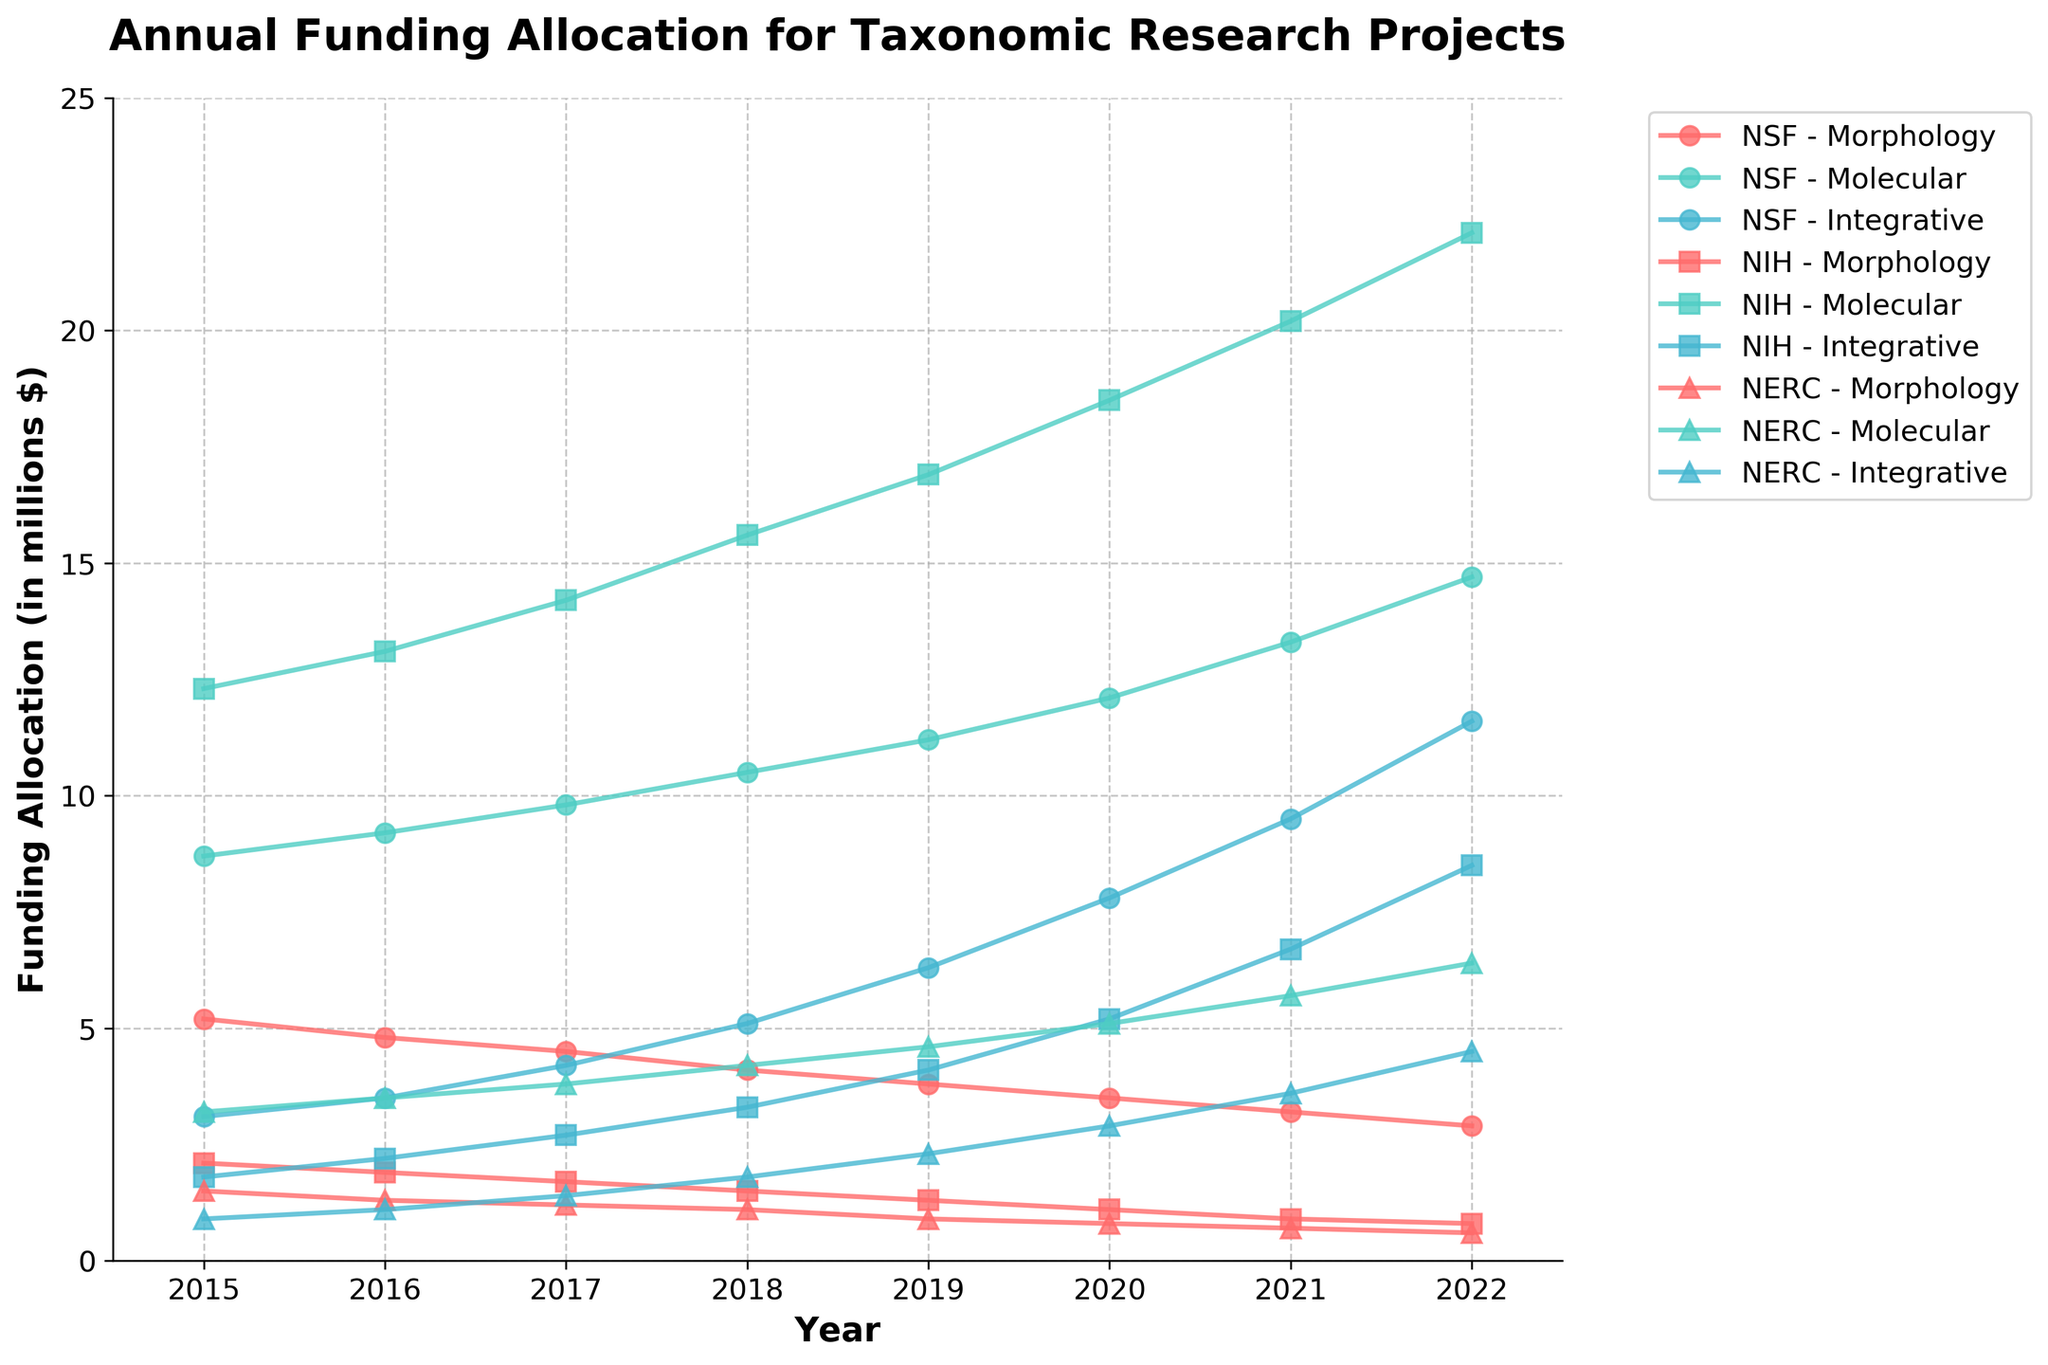What's the trend in funding allocation for NSF Morphology-based projects from 2015 to 2022? The NSF Morphology funding shows a decreasing trend. In 2015, the funding was 5.2 million, and it gradually decreased each year, reaching 2.9 million by 2022.
Answer: Decreasing trend Which research focus under NIH had the highest funding allocation in 2022? In 2022, NIH Molecular had the highest funding allocation among other NIH research focuses. The plotted line for NIH Molecular reaches approximately 22.1 million, which is the highest compared to other research focuses under NIH.
Answer: NIH Molecular Calculate the total funding allocation for NERC Integrative projects over the years. Sum the funding allocations from each year for NERC Integrative: 0.9 + 1.1 + 1.4 + 1.8 + 2.3 + 2.9 + 3.6 + 4.5 = 18.5 million.
Answer: 18.5 million Identify the agency that allocated the least amount to all taxonomic projects in 2020. By reviewing the plotted lines' values for each agency in 2020, NERC’s total is the least. Summing NERC’s values: 0.8 + 5.1 + 2.9, gives a total of 8.8 million compared to totals from NSF and NIH.
Answer: NERC By how much did NIH Morphology funding decrease from 2015 to 2022? Subtract the 2015 funding from the 2022 funding for NIH Morphology projects: 2.1 - 0.8 = 1.3 million.
Answer: 1.3 million decrease Which research focus under NSF showed the most significant increase in funding allocation from 2015 to 2022? NSF Integrative saw the most significant increase. Comparing 2015 to 2022, the funding went from 3.1 to 11.6 million.
Answer: NSF Integrative Compare the funding allocated to Molecular research focuses by NSF and NIH in 2018. Which was higher, and by how much? NSF Molecular in 2018 was 10.5 million, and NIH Molecular was 15.6 million. The difference is 15.6 - 10.5 = 5.1 million, with NIH's being higher.
Answer: NIH by 5.1 million In what year did NIH Integrative funding exceed 5 million for the first time? NIH Integrative funding first exceeds 5 million in the year 2020, reaching 5.2 million.
Answer: 2020 What is the average annual funding allocation for NSF Molecular projects from 2015 to 2022? Sum the NSF Molecular values from each year and divide by the number of years: (8.7 + 9.2 + 9.8 + 10.5 + 11.2 + 12.1 + 13.3 + 14.7) / 8 = 11.19 million.
Answer: 11.19 million 